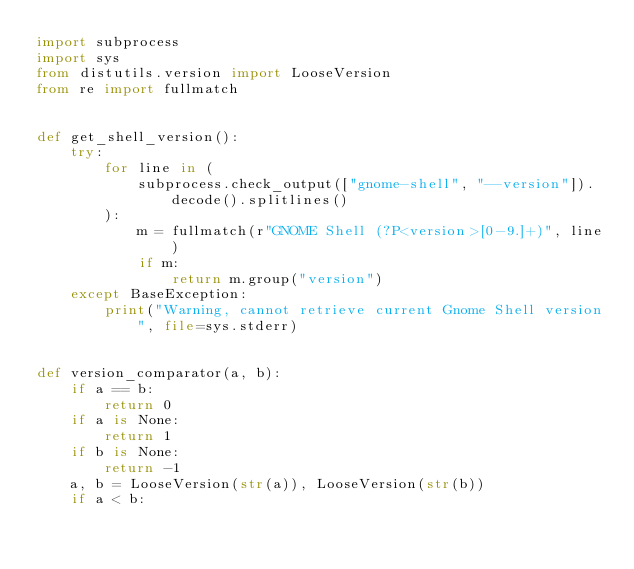Convert code to text. <code><loc_0><loc_0><loc_500><loc_500><_Python_>import subprocess
import sys
from distutils.version import LooseVersion
from re import fullmatch


def get_shell_version():
    try:
        for line in (
            subprocess.check_output(["gnome-shell", "--version"]).decode().splitlines()
        ):
            m = fullmatch(r"GNOME Shell (?P<version>[0-9.]+)", line)
            if m:
                return m.group("version")
    except BaseException:
        print("Warning, cannot retrieve current Gnome Shell version", file=sys.stderr)


def version_comparator(a, b):
    if a == b:
        return 0
    if a is None:
        return 1
    if b is None:
        return -1
    a, b = LooseVersion(str(a)), LooseVersion(str(b))
    if a < b:</code> 